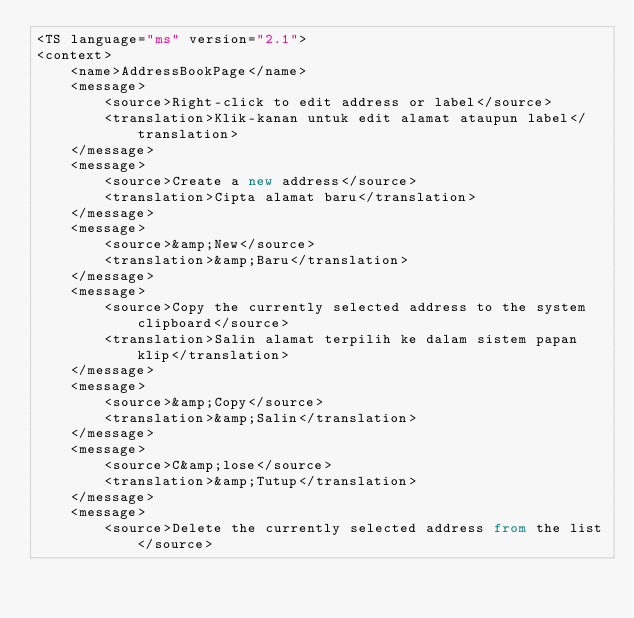<code> <loc_0><loc_0><loc_500><loc_500><_TypeScript_><TS language="ms" version="2.1">
<context>
    <name>AddressBookPage</name>
    <message>
        <source>Right-click to edit address or label</source>
        <translation>Klik-kanan untuk edit alamat ataupun label</translation>
    </message>
    <message>
        <source>Create a new address</source>
        <translation>Cipta alamat baru</translation>
    </message>
    <message>
        <source>&amp;New</source>
        <translation>&amp;Baru</translation>
    </message>
    <message>
        <source>Copy the currently selected address to the system clipboard</source>
        <translation>Salin alamat terpilih ke dalam sistem papan klip</translation>
    </message>
    <message>
        <source>&amp;Copy</source>
        <translation>&amp;Salin</translation>
    </message>
    <message>
        <source>C&amp;lose</source>
        <translation>&amp;Tutup</translation>
    </message>
    <message>
        <source>Delete the currently selected address from the list</source></code> 